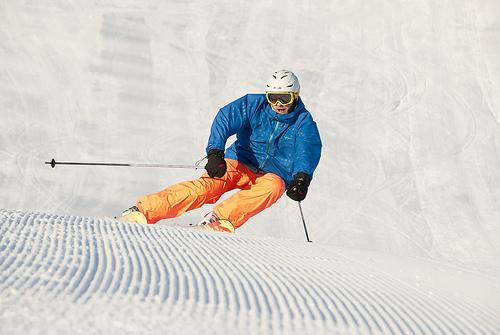Mention the key elements of the scene describing the primary subject and their activity in less than ten words. Individual skiing, helmet, goggles, jacket, gloves, poles, snow Please count the total number of times different objects or clothing are mentioned in the image description. Total: 58 mentions What is the color of the helmet that the person in the image is wearing? White Describe both the color and the position of the ski poles in the hands of the skier. The ski poles are not explicitly colored, one is in the skier's left hand stretched out, and the other is in the skier's right hand. Are there any tracks in the snow in the image? If so, what do they look like? Yes, there are tracks in the snow resulting from skiing, which appear as ridged lines in the snow. Can you tell me what the person in the image is up to in five words or less? Person skiing wearing protective gear Explain the outfit of the skier in the image with particular attention to colors and other distinguishing features. The skier wears a white helmet, yellow goggles, blue jacket, orange pants, and black gloves. They are also holding ski poles and have skis attached to their feet. In the image, what is the color of the jacket that the person is wearing, and what kind of weather is it suitable for? The jacket is blue and suitable for cold weather. Provide a brief description of the main activity happening in the image, focusing on the main character's interaction with objects. A person skiing on snow, equipped with ski poles, a helmet, goggles, and appropriate clothing, like a blue jacket and orange pants. What sentiment can be inferred from the scene captured in the image? An adventurous and active sentiment can be inferred, as the person is skiining on the snow. Does the skier have goggles? If yes, what color are they? Yes, the skier is wearing yellow goggles. Is there a dog on the snow along with the skier? No, it's not mentioned in the image. What major event is happening in the image? A person skiing on the snow Identify any text present in the image. No text is present in the image. What color are the gloves worn by the skier? The gloves are black. List all elements related to the skier's outfit in the image. White helmet, yellow goggles, blue jacket, orange snowpants, black gloves, ski pole, skis Create a short story inspired by the image. Once upon a time, on a snowy mountainside, a daring skier embarked on a solo adventure, embracing the winter’s chill as they sailed gracefully through the white landscape, leaving behind them a trail of memories and a zest for life. What is the main activity taking place in the image? Skiing What is the color of the ski pole used by the skier? The picture doesn't provide clear information about ski pole's color. Apart from the skier, what is another prominent feature in the image? Ridges and tracks in the snow Describe the orange snowpants worn by the skier. The orange snowpants are worn on the skier's legs, covering both knees and extending down to partially cover the skier's ski boots. Describe the position of the ski pole. The ski pole is stretched out and held in both the skier's right and left hands. Draw an outline of the path created by the skier. A curvy line following the tracks in the snow What are the colors of the skier's outfit? White helmet, blue jacket, orange snowpants, black gloves, yellow goggles Describe the scene in the style of a Romantic poet. Amidst the vast snowy expanse, a lone skier ventures forth, adorned in hues of alabaster, azure, and sun-kissed orange, weaving tracks in the ivory blanket beneath. Which hand is the ski pole in for the skier? The ski pole is in both hands, right and left. Write a newspaper headline for the image. A Daring Solo Ski Adventure: Conquering the Snowy Mountainside 